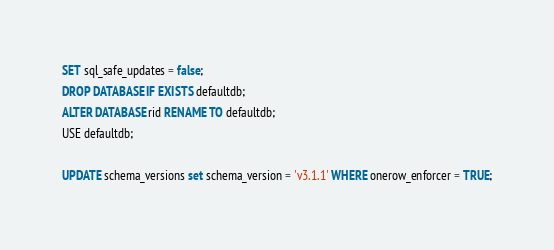Convert code to text. <code><loc_0><loc_0><loc_500><loc_500><_SQL_>SET sql_safe_updates = false;
DROP DATABASE IF EXISTS defaultdb;
ALTER DATABASE rid RENAME TO defaultdb;
USE defaultdb;

UPDATE schema_versions set schema_version = 'v3.1.1' WHERE onerow_enforcer = TRUE;
</code> 